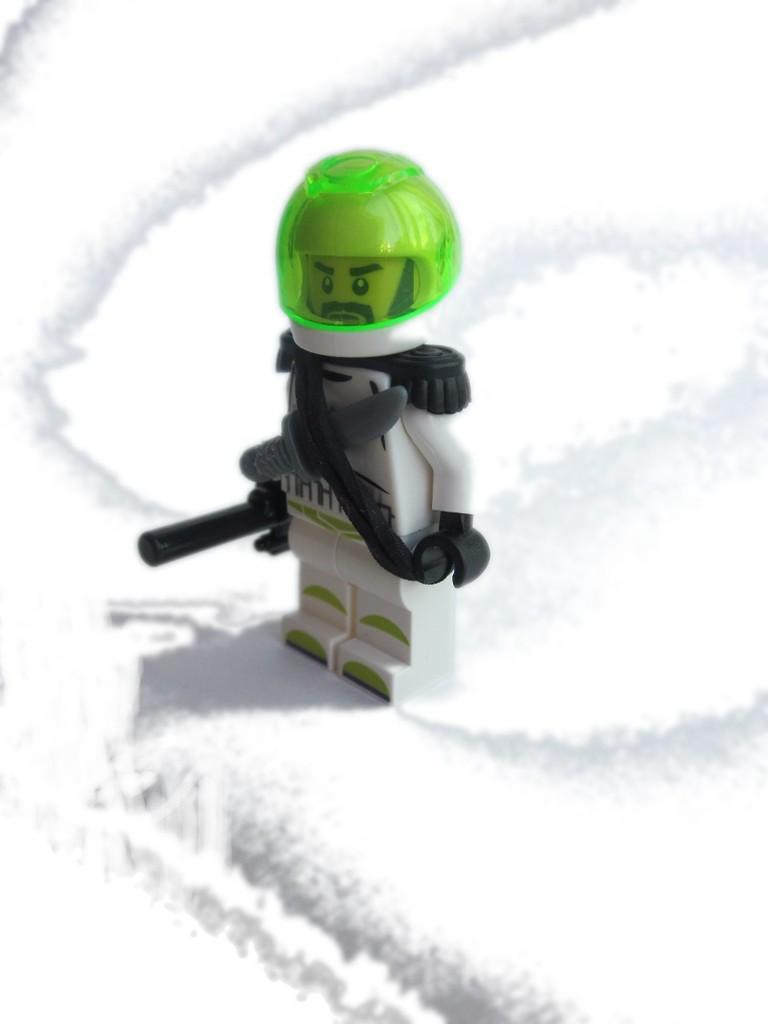What is the main object in the image? There is a toy in the image. What colors can be seen on the toy? The toy has green, white, ash, and black colors. What type of accessory is associated with the toy? There is a green color helmet associated with the toy. Where is the toy located? The toy is on the snow. How many crates are stacked next to the toy in the image? There are no crates present in the image. What type of machine is visible in the background of the image? There is no machine visible in the image; it only features the toy and the snow. 